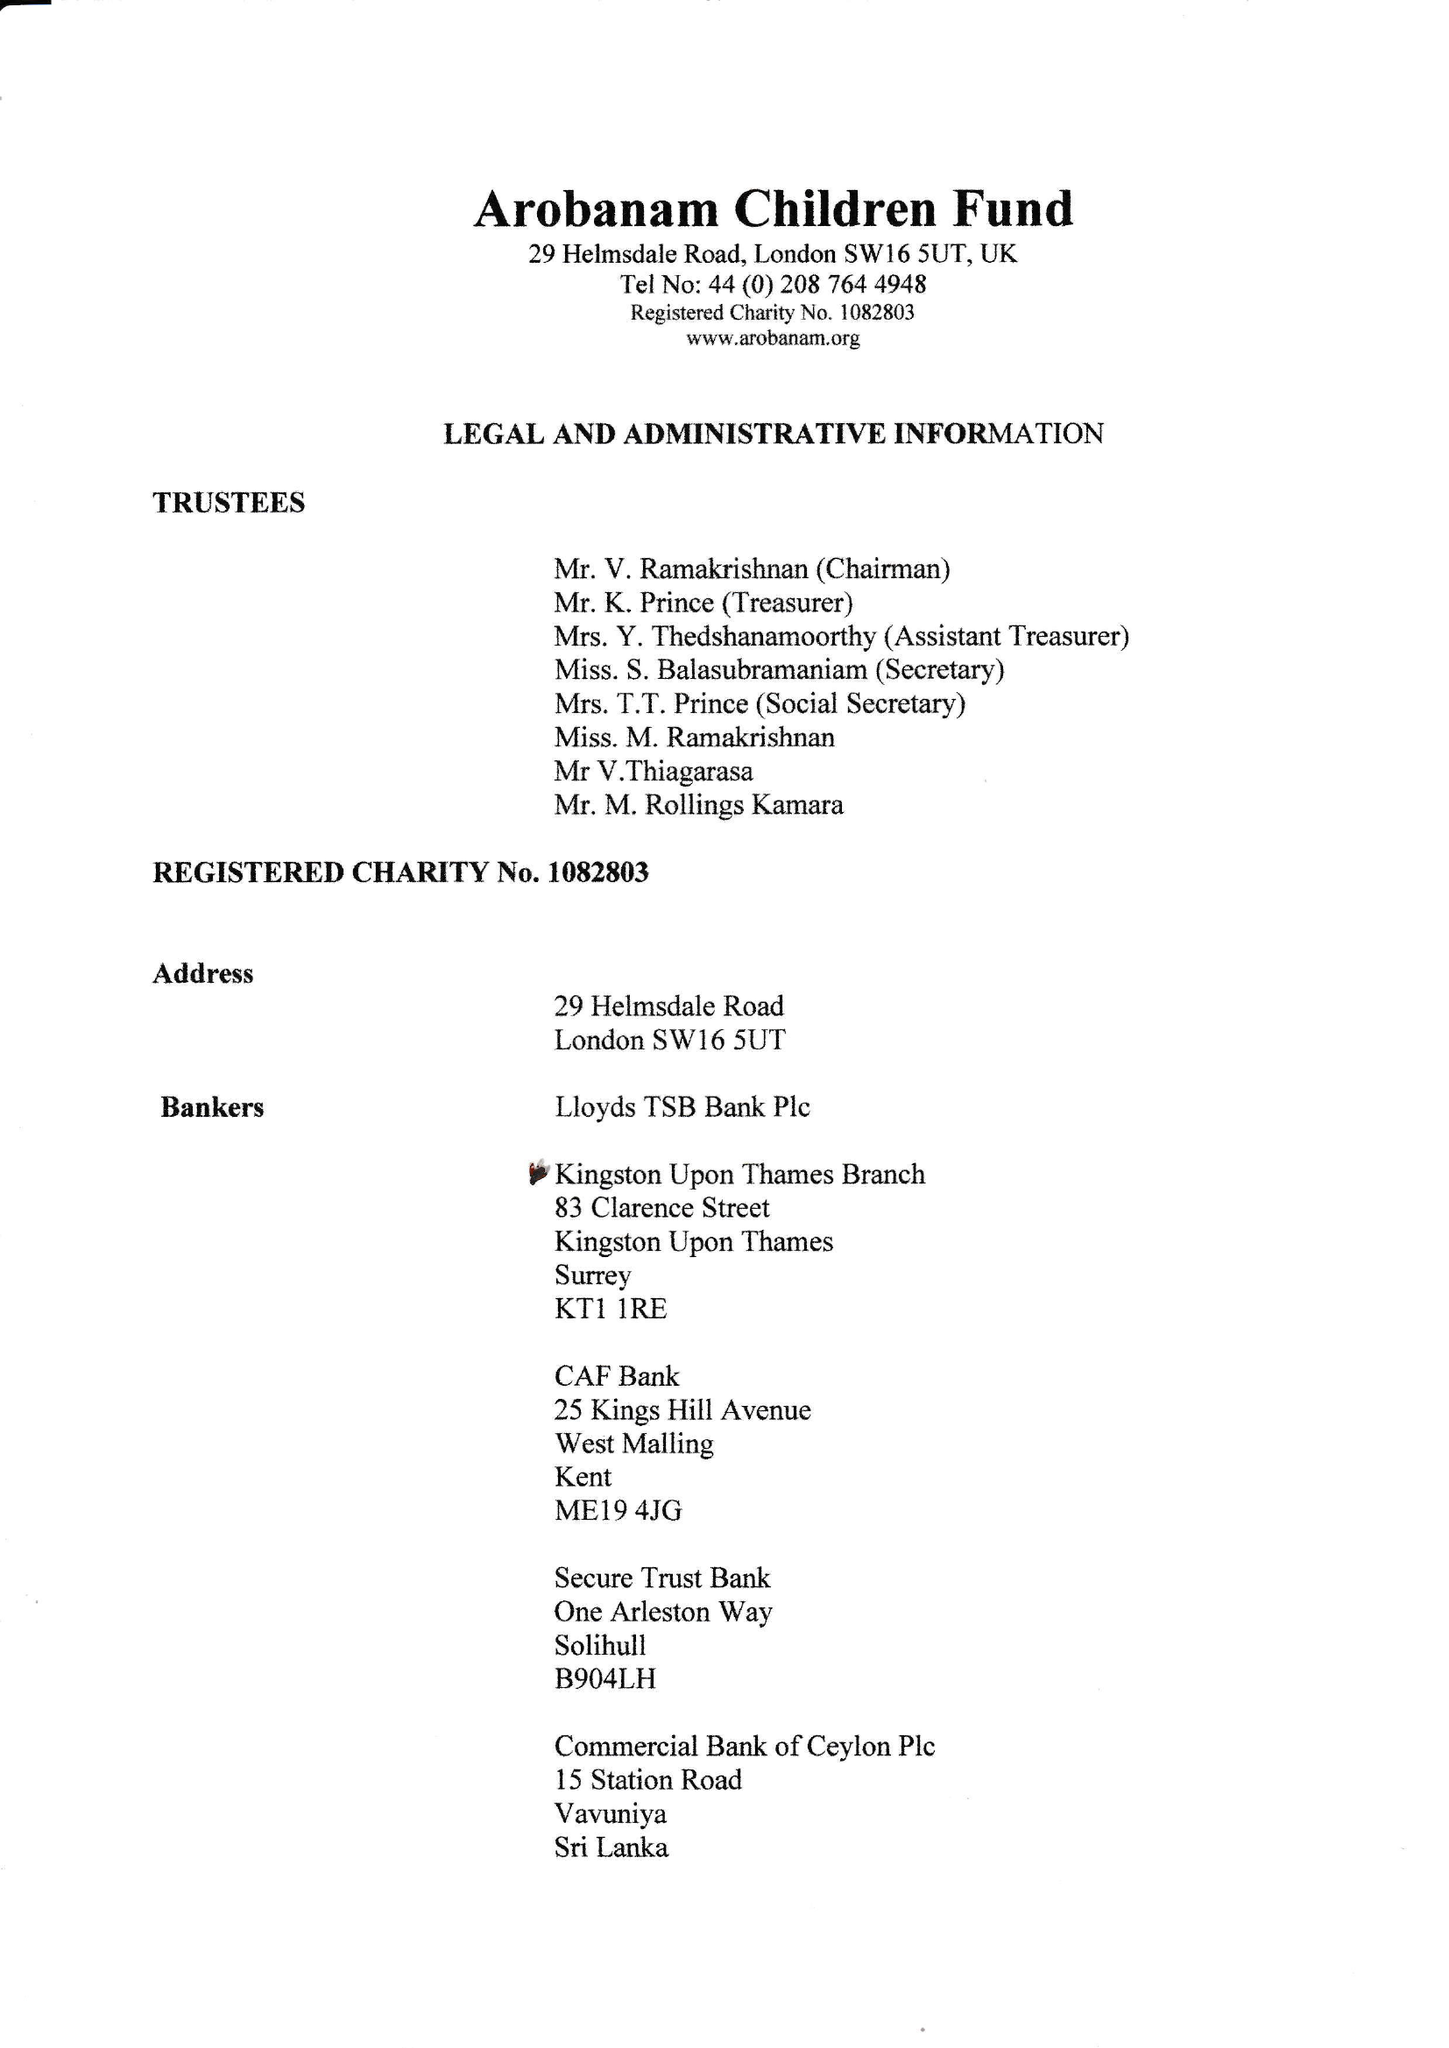What is the value for the address__post_town?
Answer the question using a single word or phrase. LONDON 